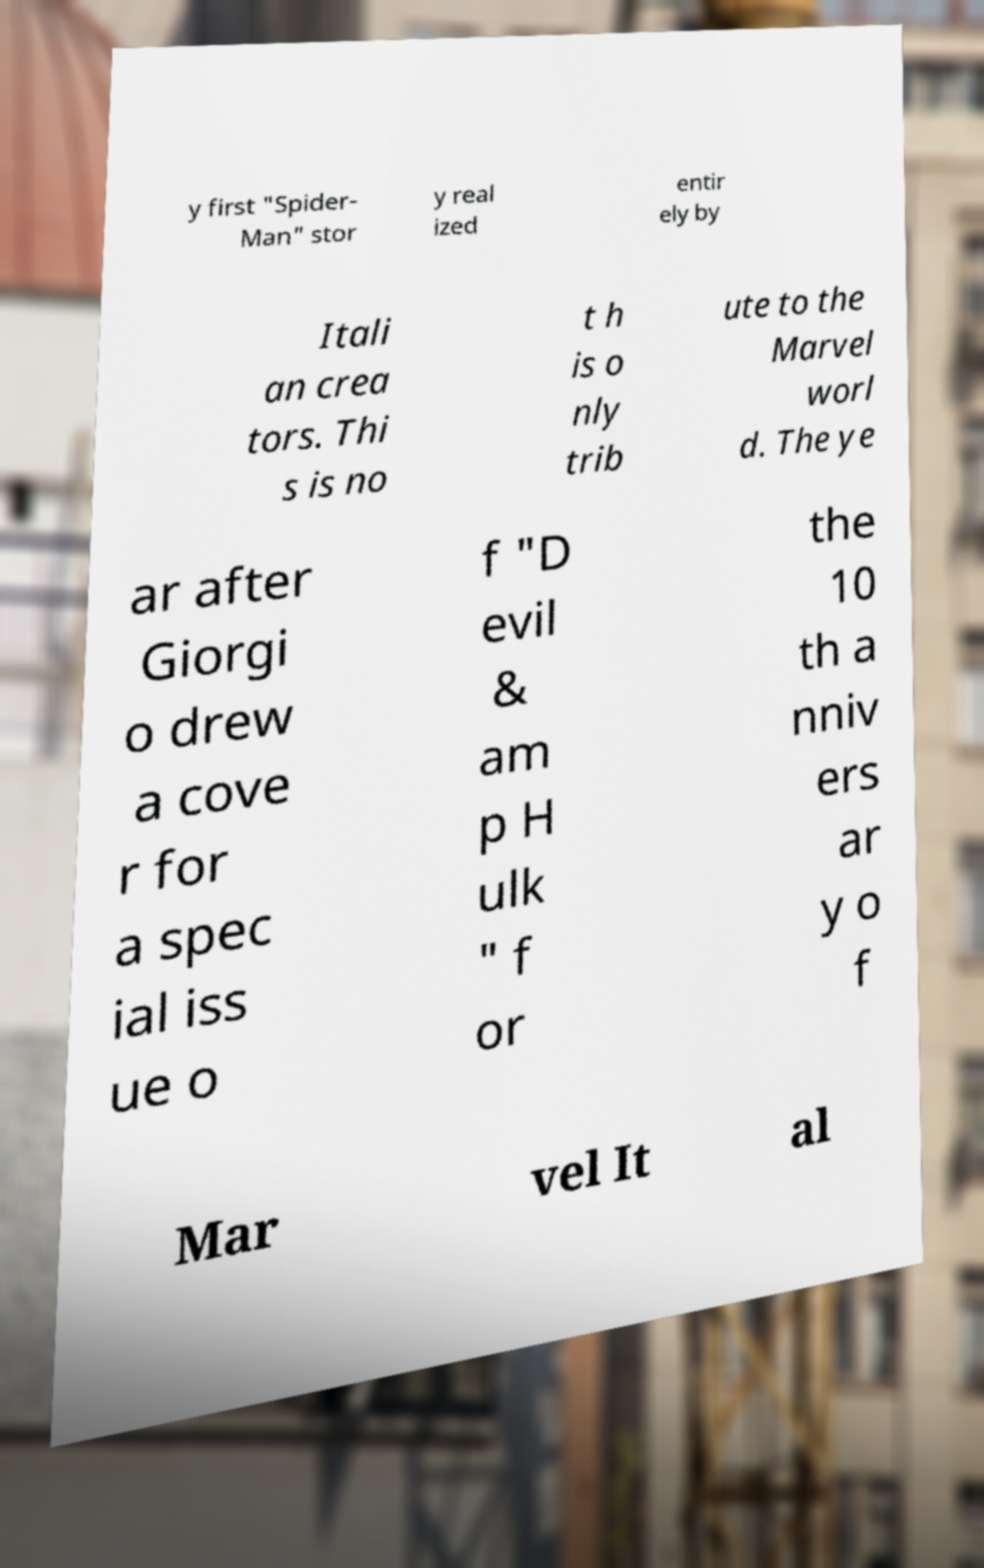I need the written content from this picture converted into text. Can you do that? y first "Spider- Man" stor y real ized entir ely by Itali an crea tors. Thi s is no t h is o nly trib ute to the Marvel worl d. The ye ar after Giorgi o drew a cove r for a spec ial iss ue o f "D evil & am p H ulk " f or the 10 th a nniv ers ar y o f Mar vel It al 